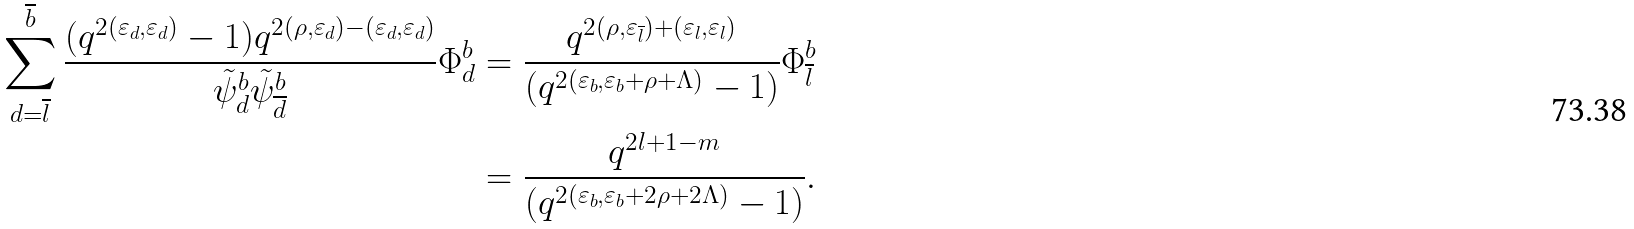<formula> <loc_0><loc_0><loc_500><loc_500>\sum _ { d = \overline { l } } ^ { \overline { b } } \frac { ( q ^ { 2 ( \varepsilon _ { d } , \varepsilon _ { d } ) } - 1 ) q ^ { 2 ( \rho , \varepsilon _ { d } ) - ( \varepsilon _ { d } , \varepsilon _ { d } ) } } { \tilde { \psi } ^ { b } _ { d } \tilde { \psi } ^ { b } _ { \overline { d } } } \Phi ^ { b } _ { d } & = \frac { q ^ { 2 ( \rho , \varepsilon _ { \overline { l } } ) + ( \varepsilon _ { l } , \varepsilon _ { l } ) } } { ( q ^ { 2 ( \varepsilon _ { b } , \varepsilon _ { b } + \rho + \Lambda ) } - 1 ) } \Phi ^ { b } _ { \overline { l } } \\ & = \frac { q ^ { 2 l + 1 - m } } { ( q ^ { 2 ( \varepsilon _ { b } , \varepsilon _ { b } + 2 \rho + 2 \Lambda ) } - 1 ) } .</formula> 